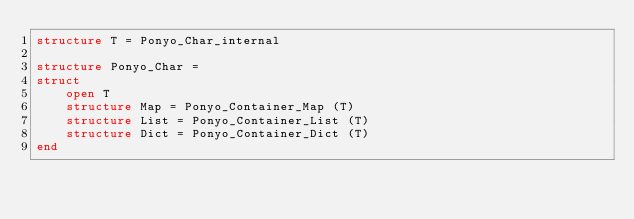<code> <loc_0><loc_0><loc_500><loc_500><_SML_>structure T = Ponyo_Char_internal

structure Ponyo_Char =
struct
    open T
    structure Map = Ponyo_Container_Map (T)
    structure List = Ponyo_Container_List (T)
    structure Dict = Ponyo_Container_Dict (T)
end
</code> 